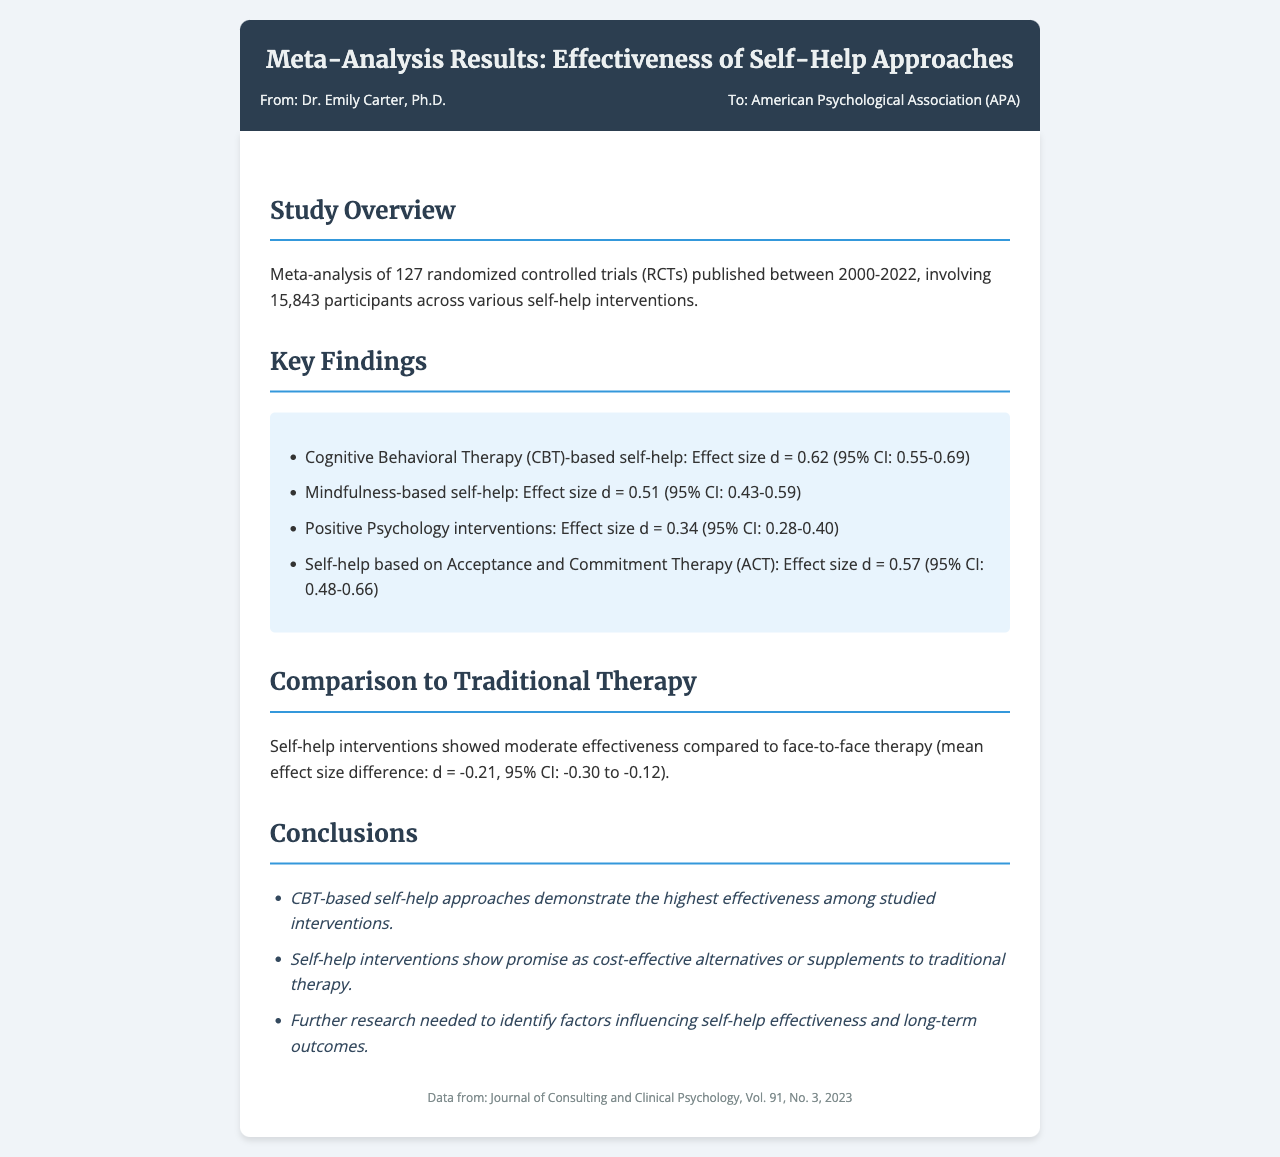What was the total number of participants in the meta-analysis? The total number of participants is mentioned as 15,843 across various self-help interventions.
Answer: 15,843 What is the effect size for CBT-based self-help? The document states the effect size for CBT-based self-help is d = 0.62 with a 95% confidence interval provided.
Answer: 0.62 Which self-help approach had the lowest effect size? The lowest effect size is listed for Positive Psychology interventions.
Answer: Positive Psychology What is the mean effect size difference compared to traditional therapy? The mean effect size difference is given as d = -0.21 with a confidence interval.
Answer: d = -0.21 What type of document is this? The document is a fax summarizing the results of a meta-analysis on self-help approaches.
Answer: Fax What year range do the included studies cover? The studies analyzed were published between 2000 and 2022, according to the overview.
Answer: 2000-2022 What does the meta-analysis suggest about self-help interventions? The conclusion states that self-help interventions show promise as cost-effective alternatives or supplements to traditional therapy.
Answer: Cost-effective alternatives Which therapy-based self-help approach shows the highest effectiveness? The document highlights that CBT-based self-help approaches demonstrate the highest effectiveness among the studied interventions.
Answer: CBT-based self-help What is one of the recommendations for future research? It mentions that further research is needed to identify factors influencing self-help effectiveness and long-term outcomes.
Answer: Factors influencing effectiveness 